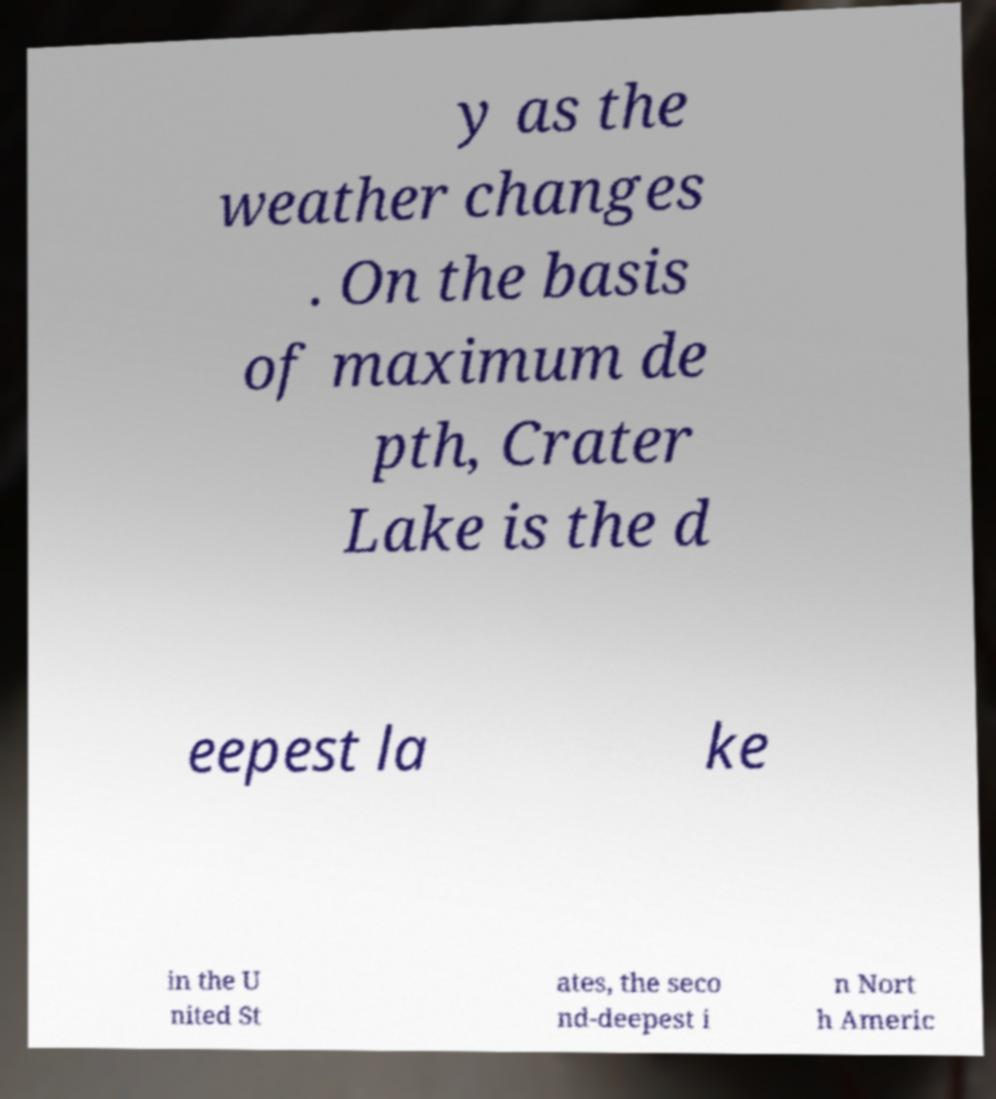Please read and relay the text visible in this image. What does it say? y as the weather changes . On the basis of maximum de pth, Crater Lake is the d eepest la ke in the U nited St ates, the seco nd-deepest i n Nort h Americ 